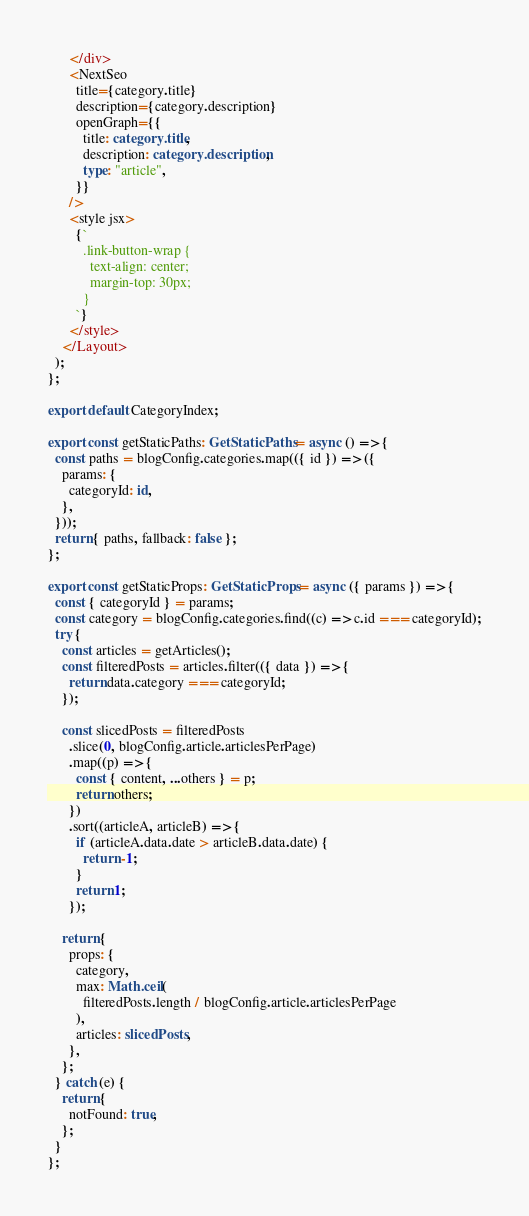<code> <loc_0><loc_0><loc_500><loc_500><_TypeScript_>      </div>
      <NextSeo
        title={category.title}
        description={category.description}
        openGraph={{
          title: category.title,
          description: category.description,
          type: "article",
        }}
      />
      <style jsx>
        {`
          .link-button-wrap {
            text-align: center;
            margin-top: 30px;
          }
        `}
      </style>
    </Layout>
  );
};

export default CategoryIndex;

export const getStaticPaths: GetStaticPaths = async () => {
  const paths = blogConfig.categories.map(({ id }) => ({
    params: {
      categoryId: id,
    },
  }));
  return { paths, fallback: false };
};

export const getStaticProps: GetStaticProps = async ({ params }) => {
  const { categoryId } = params;
  const category = blogConfig.categories.find((c) => c.id === categoryId);
  try {
    const articles = getArticles();
    const filteredPosts = articles.filter(({ data }) => {
      return data.category === categoryId;
    });

    const slicedPosts = filteredPosts
      .slice(0, blogConfig.article.articlesPerPage)
      .map((p) => {
        const { content, ...others } = p;
        return others;
      })
      .sort((articleA, articleB) => {
        if (articleA.data.date > articleB.data.date) {
          return -1;
        }
        return 1;
      });

    return {
      props: {
        category,
        max: Math.ceil(
          filteredPosts.length / blogConfig.article.articlesPerPage
        ),
        articles: slicedPosts,
      },
    };
  } catch (e) {
    return {
      notFound: true,
    };
  }
};
</code> 